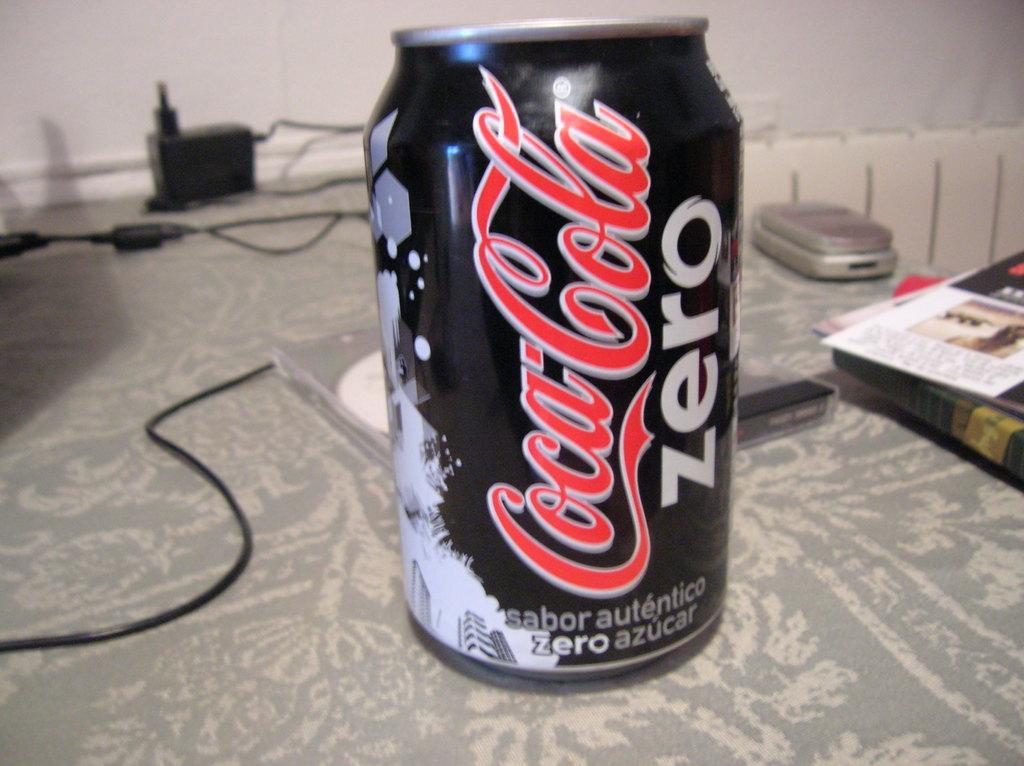What type of beverage container is in the image? There is a coca-cola tin in the image. What type of reading material is in the image? There is a newspaper in the image. What type of communication device is in the image? There is a mobile phone in the image. What is used to charge the mobile phone in the image? There is a charger in the image. Where are all the objects located in the image? All objects are on a table. What type of rod is used to rub the newspaper in the image? There is no rod present in the image, nor is there any rubbing of the newspaper. 